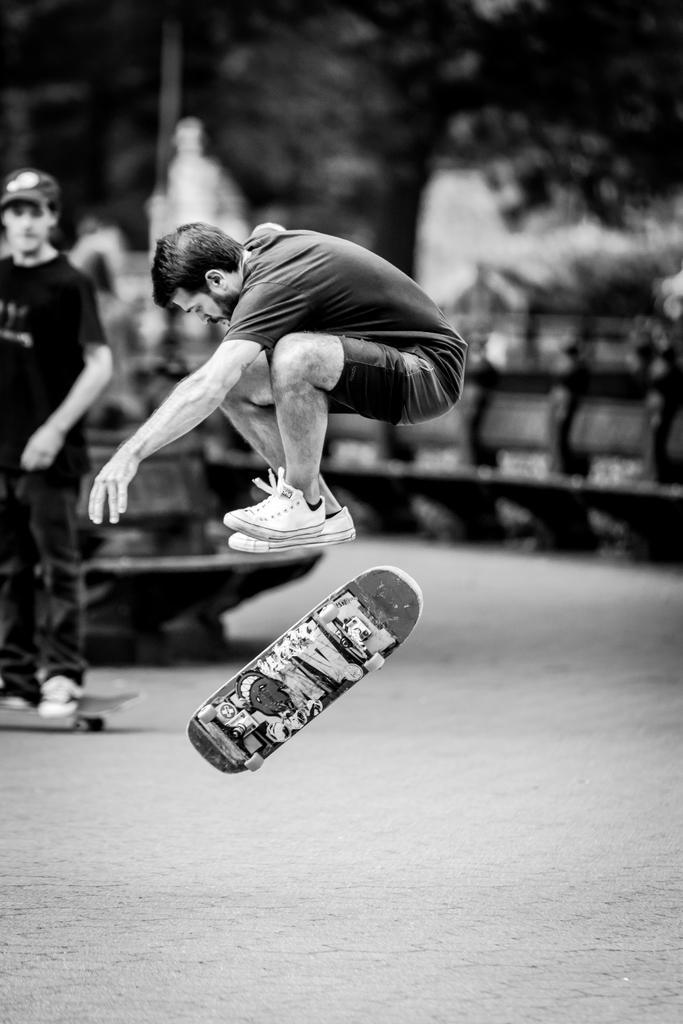Please provide a concise description of this image. It is a black and white image, there is a person jumping from a skating board and the skating board is above the ground, behind the person there is another man and the background is blurry. 